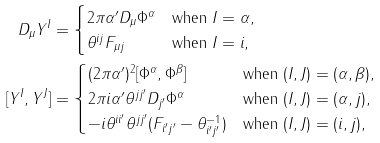Convert formula to latex. <formula><loc_0><loc_0><loc_500><loc_500>D _ { \mu } Y ^ { I } & = \begin{cases} 2 \pi \alpha ^ { \prime } D _ { \mu } \Phi ^ { \alpha } & \text {when $I=\alpha$} , \\ \theta ^ { i j } F _ { \mu j } & \text {when $I=i$} , \end{cases} \\ [ Y ^ { I } , Y ^ { J } ] & = \begin{cases} ( 2 \pi \alpha ^ { \prime } ) ^ { 2 } [ \Phi ^ { \alpha } , \Phi ^ { \beta } ] & \text {when $(I, J)=(\alpha, \beta)$} , \\ 2 \pi i \alpha ^ { \prime } \theta ^ { j j ^ { \prime } } D _ { j ^ { \prime } } \Phi ^ { \alpha } & \text {when $(I, J)=(\alpha, j)$} , \\ - i \theta ^ { i i ^ { \prime } } \theta ^ { j j ^ { \prime } } ( F _ { i ^ { \prime } j ^ { \prime } } - \theta ^ { - 1 } _ { i ^ { \prime } j ^ { \prime } } ) & \text {when $(I, J)=(i, j)$} , \end{cases}</formula> 